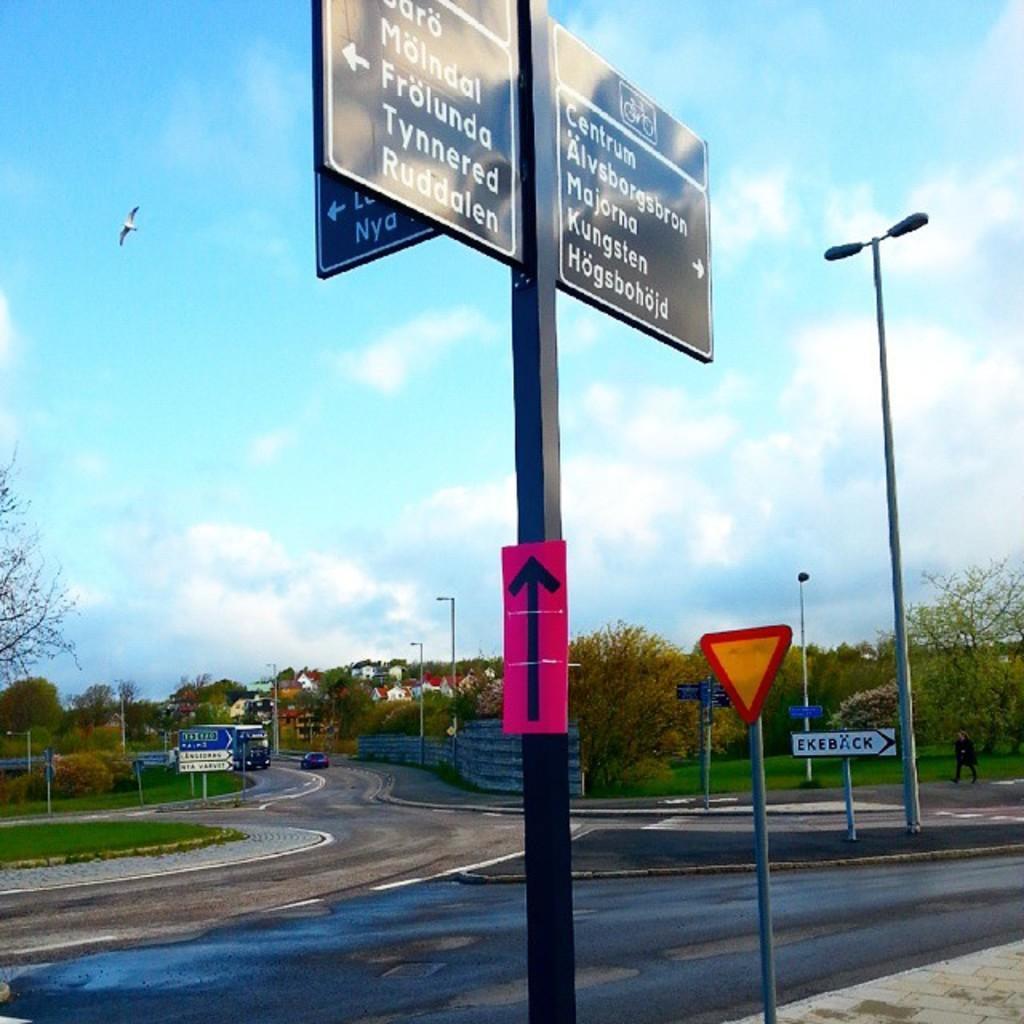Could you give a brief overview of what you see in this image? There is a car and a vehicle are on the road. A person is walking on the pavement. There are street lights and few poles with the boards are on the pavement, beside there is grassland having few trees. Behind there are few buildings. Top of image there is sky with some clouds. Front side of image there is a pole with some direction boards attached to it. Beside there is a pole having a caution board attached to it are on the pavement. A bird is flying in the air. 